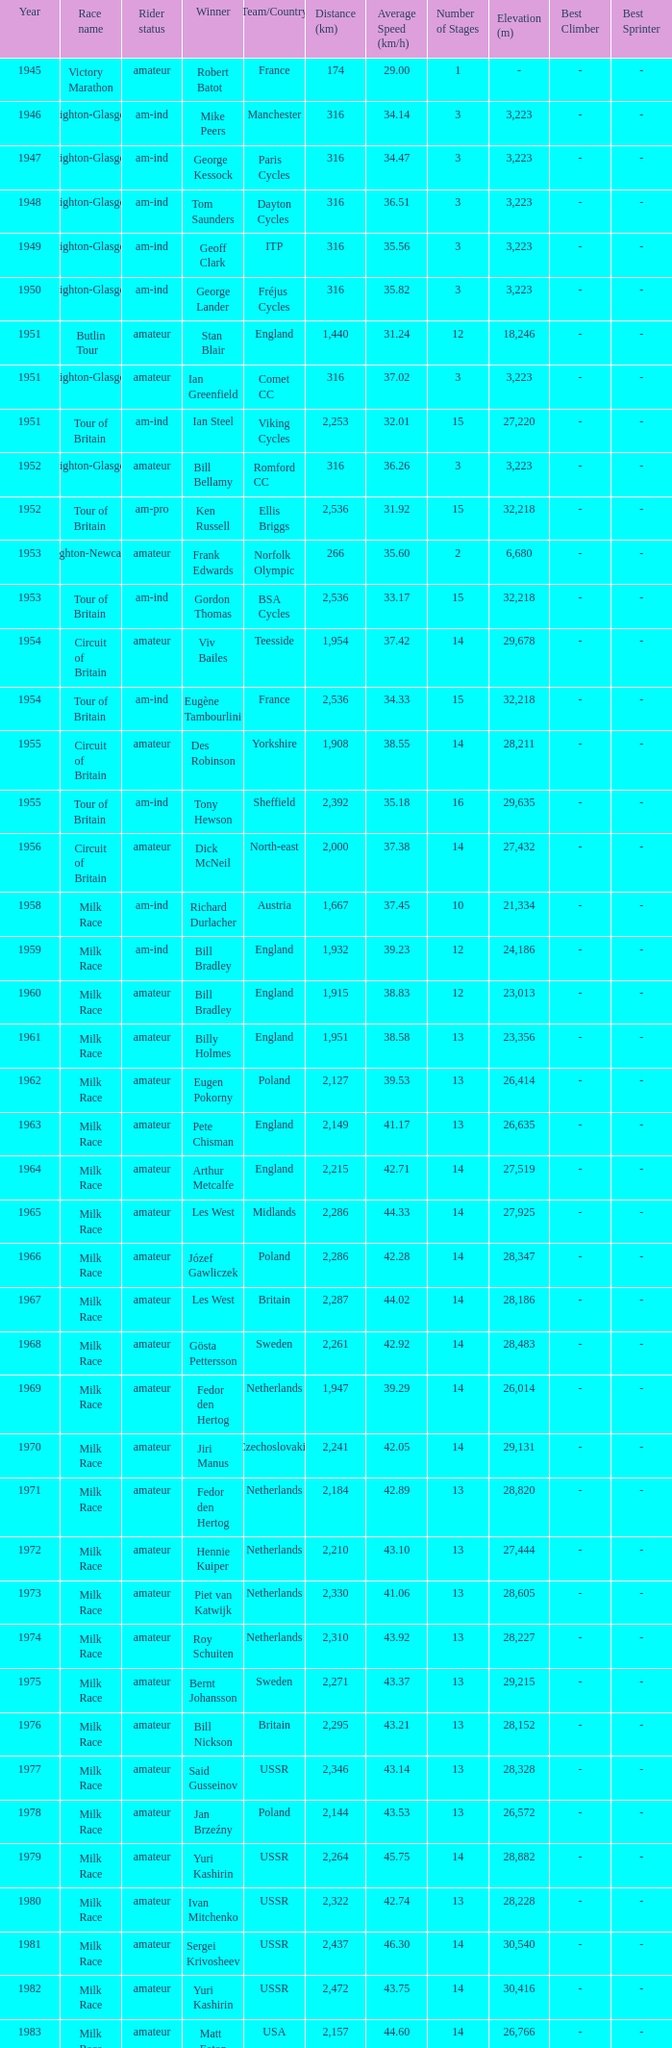What is the latest year when Phil Anderson won? 1993.0. 